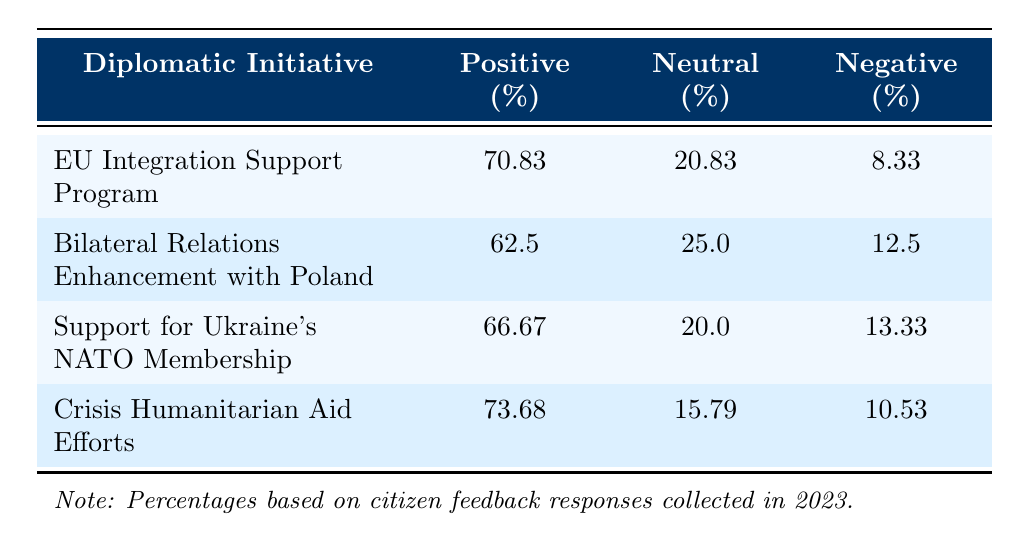What is the percentage of positive feedback for the "Crisis Humanitarian Aid Efforts" initiative? The table indicates that the percentage of positive feedback for the "Crisis Humanitarian Aid Efforts" initiative is located in the corresponding row under the Positive (%) column. It shows that 73.68% of the feedback received was positive.
Answer: 73.68% Which initiative received the least percentage of positive feedback? By comparing the percentages in the Positive (%) column, "Bilateral Relations Enhancement with Poland" has 62.5%, which is the lowest among all the initiatives listed in the table.
Answer: Bilateral Relations Enhancement with Poland What is the average percentage of neutral feedback across all initiatives? To calculate the average, first sum the neutral feedback percentages: 20.83 + 25.0 + 20.0 + 15.79 = 81.62. Then divide by the number of initiatives (4). The average is 81.62 / 4 = 20.405.
Answer: 20.405% Is the percentage of negative feedback for the "Support for Ukraine's NATO Membership" higher than that of the "EU Integration Support Program"? The negative feedback percentages are listed as 13.33% for "Support for Ukraine's NATO Membership" and 8.33% for the "EU Integration Support Program." Since 13.33 is greater than 8.33, the statement is true.
Answer: Yes How many total feedback responses were received for the "EU Integration Support Program"? According to the table, the total feedback responses for the "EU Integration Support Program" are explicitly stated under the Total Feedback Responses column, which is 1200.
Answer: 1200 What is the combined percentage of neutral and negative feedback for the "Bilateral Relations Enhancement with Poland"? To find the combined percentage, add the neutral (25.0%) and negative (12.5%) feedback percentages together: 25.0 + 12.5 = 37.5%. This value represents the total percentage of neutral and negative feedback for that initiative.
Answer: 37.5% Which initiative has the highest percentage of positive feedback and what is that percentage? By checking the percentages in the Positive (%) column, "Crisis Humanitarian Aid Efforts" shows the highest percentage at 73.68%. Therefore, it has the highest positive feedback percentage among the initiatives.
Answer: Crisis Humanitarian Aid Efforts, 73.68% Are the most common negative comments the same for all initiatives? The table provides distinct negative comments for each initiative. Since the comments listed under "most common negative comments" vary for each initiative, the statement is false.
Answer: No 